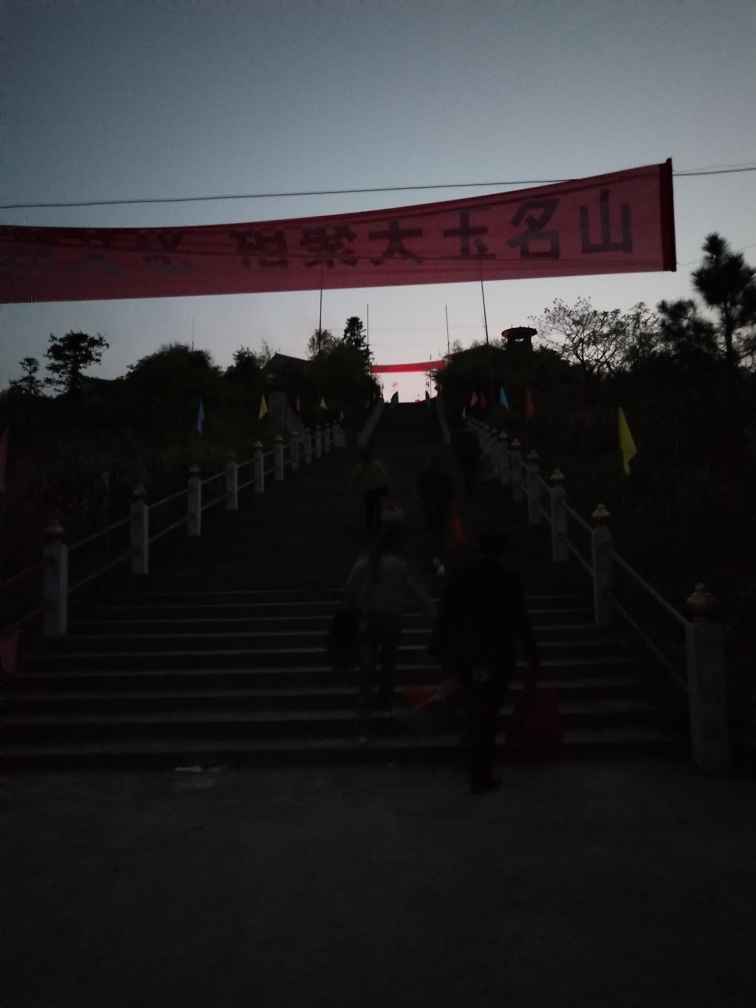Can you provide more context about the setting depicted in the image? The image appears to capture a scene during twilight or early evening at a location that may serve as a public or ceremonial space, indicated by the presence of the large banner with text and flags ascended along steps leading to what could be a building or monument. The low light conditions suggest the photo was taken at a time when natural light was fading. 